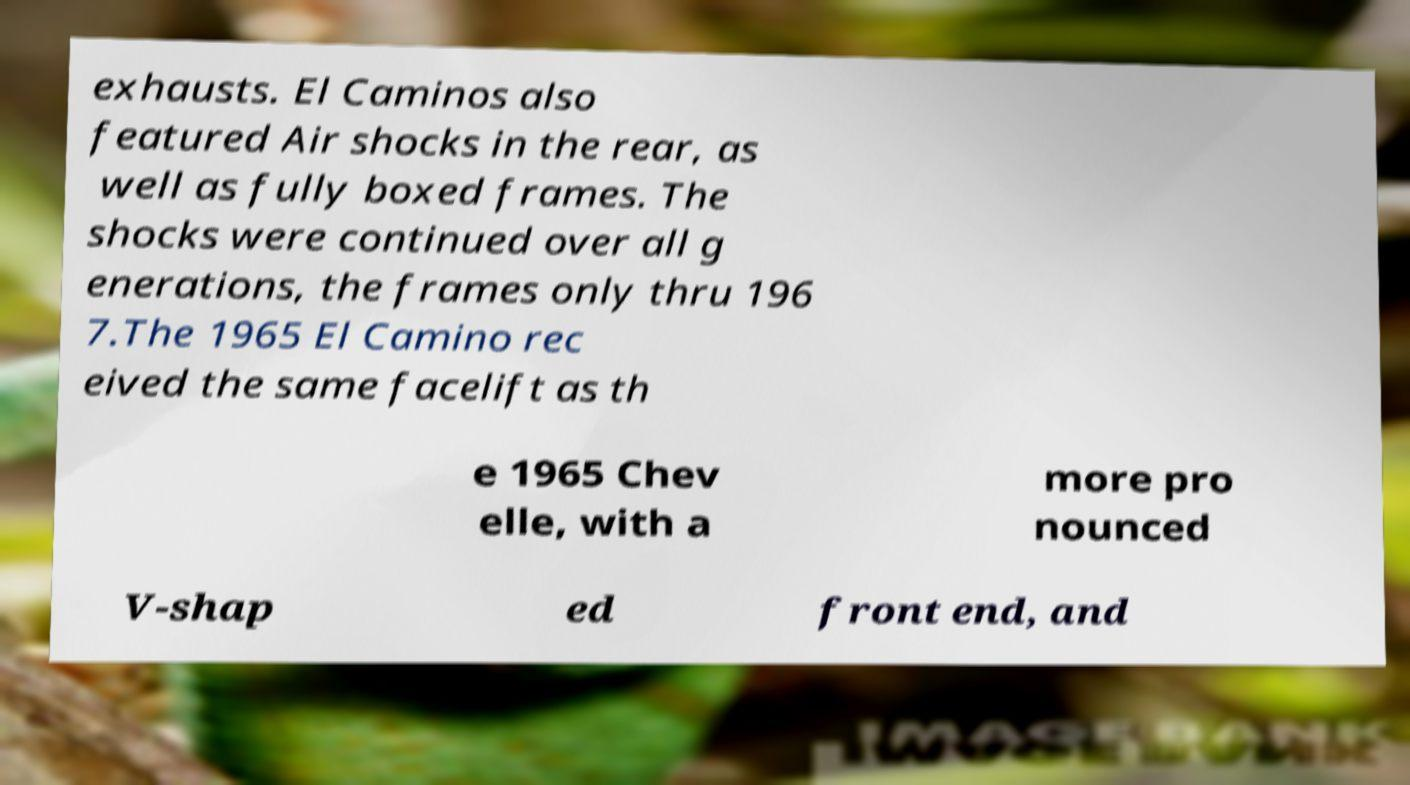Could you assist in decoding the text presented in this image and type it out clearly? exhausts. El Caminos also featured Air shocks in the rear, as well as fully boxed frames. The shocks were continued over all g enerations, the frames only thru 196 7.The 1965 El Camino rec eived the same facelift as th e 1965 Chev elle, with a more pro nounced V-shap ed front end, and 